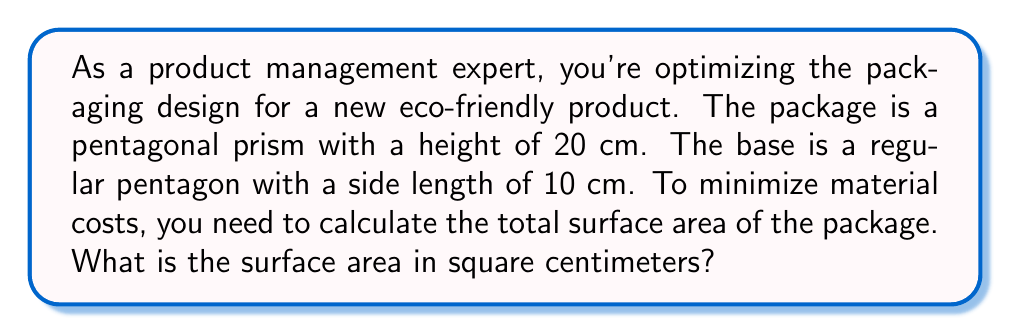Show me your answer to this math problem. Let's break this down step-by-step:

1) First, we need to calculate the area of the pentagonal base. For a regular pentagon with side length $s$, the area is given by:

   $$A_{base} = \frac{1}{4}\sqrt{25+10\sqrt{5}}s^2$$

2) Substituting $s = 10$ cm:

   $$A_{base} = \frac{1}{4}\sqrt{25+10\sqrt{5}}(10)^2 = 25\sqrt{25+10\sqrt{5}} \approx 172.05 \text{ cm}^2$$

3) We need this area twice (for top and bottom), so:

   $$A_{top+bottom} = 2 \times 25\sqrt{25+10\sqrt{5}} \approx 344.10 \text{ cm}^2$$

4) For the lateral surface area, we need to calculate the area of 5 rectangles. Each rectangle has a width of 10 cm (the side length of the pentagon) and a height of 20 cm. So the area of each rectangle is:

   $$A_{rectangle} = 10 \times 20 = 200 \text{ cm}^2$$

5) The total lateral surface area is:

   $$A_{lateral} = 5 \times 200 = 1000 \text{ cm}^2$$

6) The total surface area is the sum of the top, bottom, and lateral areas:

   $$A_{total} = A_{top+bottom} + A_{lateral}$$
   $$A_{total} = 2 \times 25\sqrt{25+10\sqrt{5}} + 1000$$
   $$A_{total} = 50\sqrt{25+10\sqrt{5}} + 1000 \approx 1344.10 \text{ cm}^2$$

[asy]
import geometry;

size(200);

pair A = (0,0), B = (2,0), C = (2.618,1.902), D = (1,3.078), E = (-0.618,1.902);
path p = A--B--C--D--E--cycle;
draw(p);
draw(shift(0,4)*p);
draw(A--(0,4), dashed);
draw(B--(2,4), dashed);
draw(C--(2.618,5.902), dashed);
draw(D--(1,7.078), dashed);
draw(E--(-0.618,5.902), dashed);

label("10 cm", (A+B)/2, S);
label("20 cm", (A+(0,4))/2 + (0.3,0), E);
[/asy]
Answer: $50\sqrt{25+10\sqrt{5}} + 1000 \approx 1344.10 \text{ cm}^2$ 